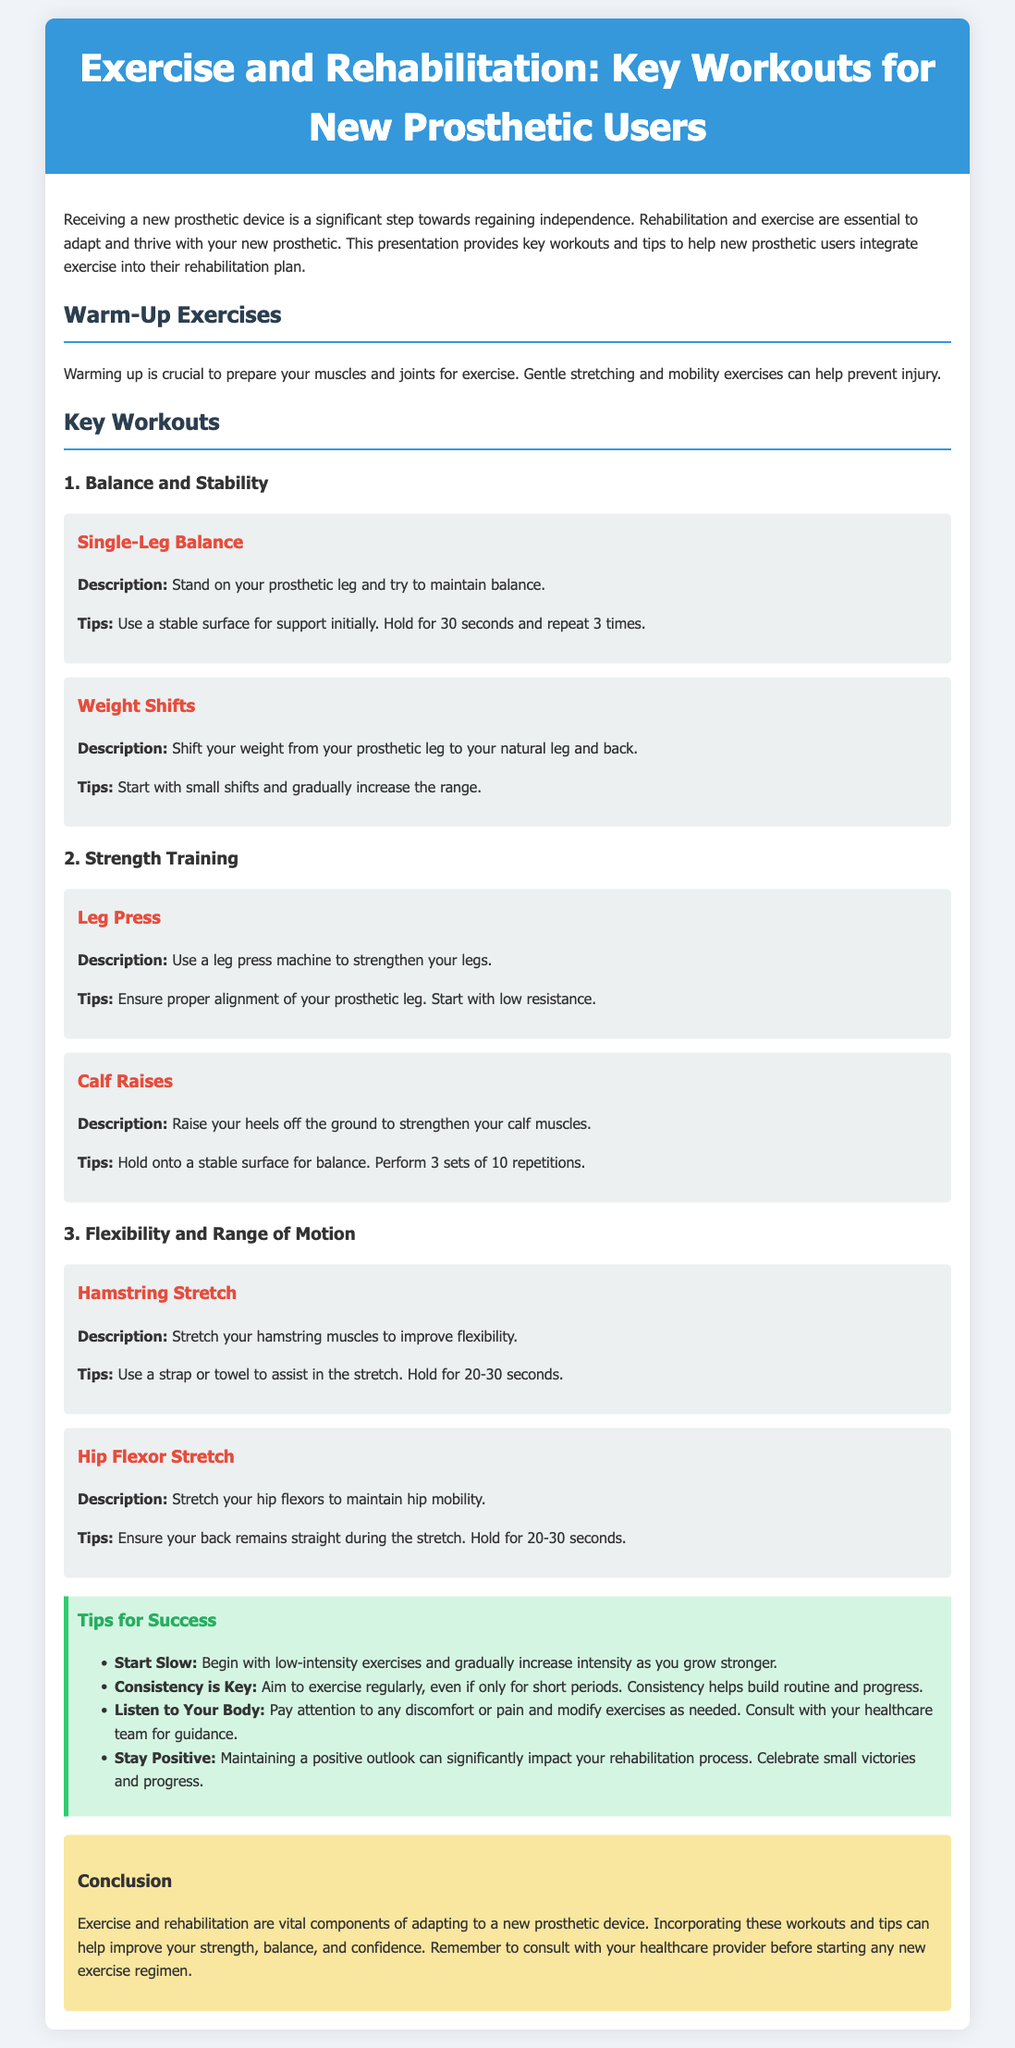What is the title of the presentation? The title of the presentation is located at the top of the document and specifies the main topic.
Answer: Exercise and Rehabilitation: Key Workouts for New Prosthetic Users How many key workouts are listed? The document outlines three distinct categories of key workouts for new prosthetic users.
Answer: 3 What is the recommended hold time for the Single-Leg Balance exercise? The document explicitly states the duration for holding the position during the exercise.
Answer: 30 seconds What is a tip for success mentioned in the document? The document contains a section that lists various success tips for rehabilitation, indicating general advice provided.
Answer: Start Slow Which exercise focuses on flexibility? This exercise is specifically aimed at improving flexibility and is included within a section outlining different exercises.
Answer: Hamstring Stretch What color is used for the tips background? The document describes the color scheme of various sections, identifying the color associated with tips.
Answer: Light green What is advised before starting any new exercise regimen? The document emphasizes consultation with a specific group or individual before beginning exercises.
Answer: Healthcare provider How many repetitions are recommended for the Calf Raises exercise? The document specifies a particular quantity for repetitions as part of the exercise instructions.
Answer: 10 repetitions 